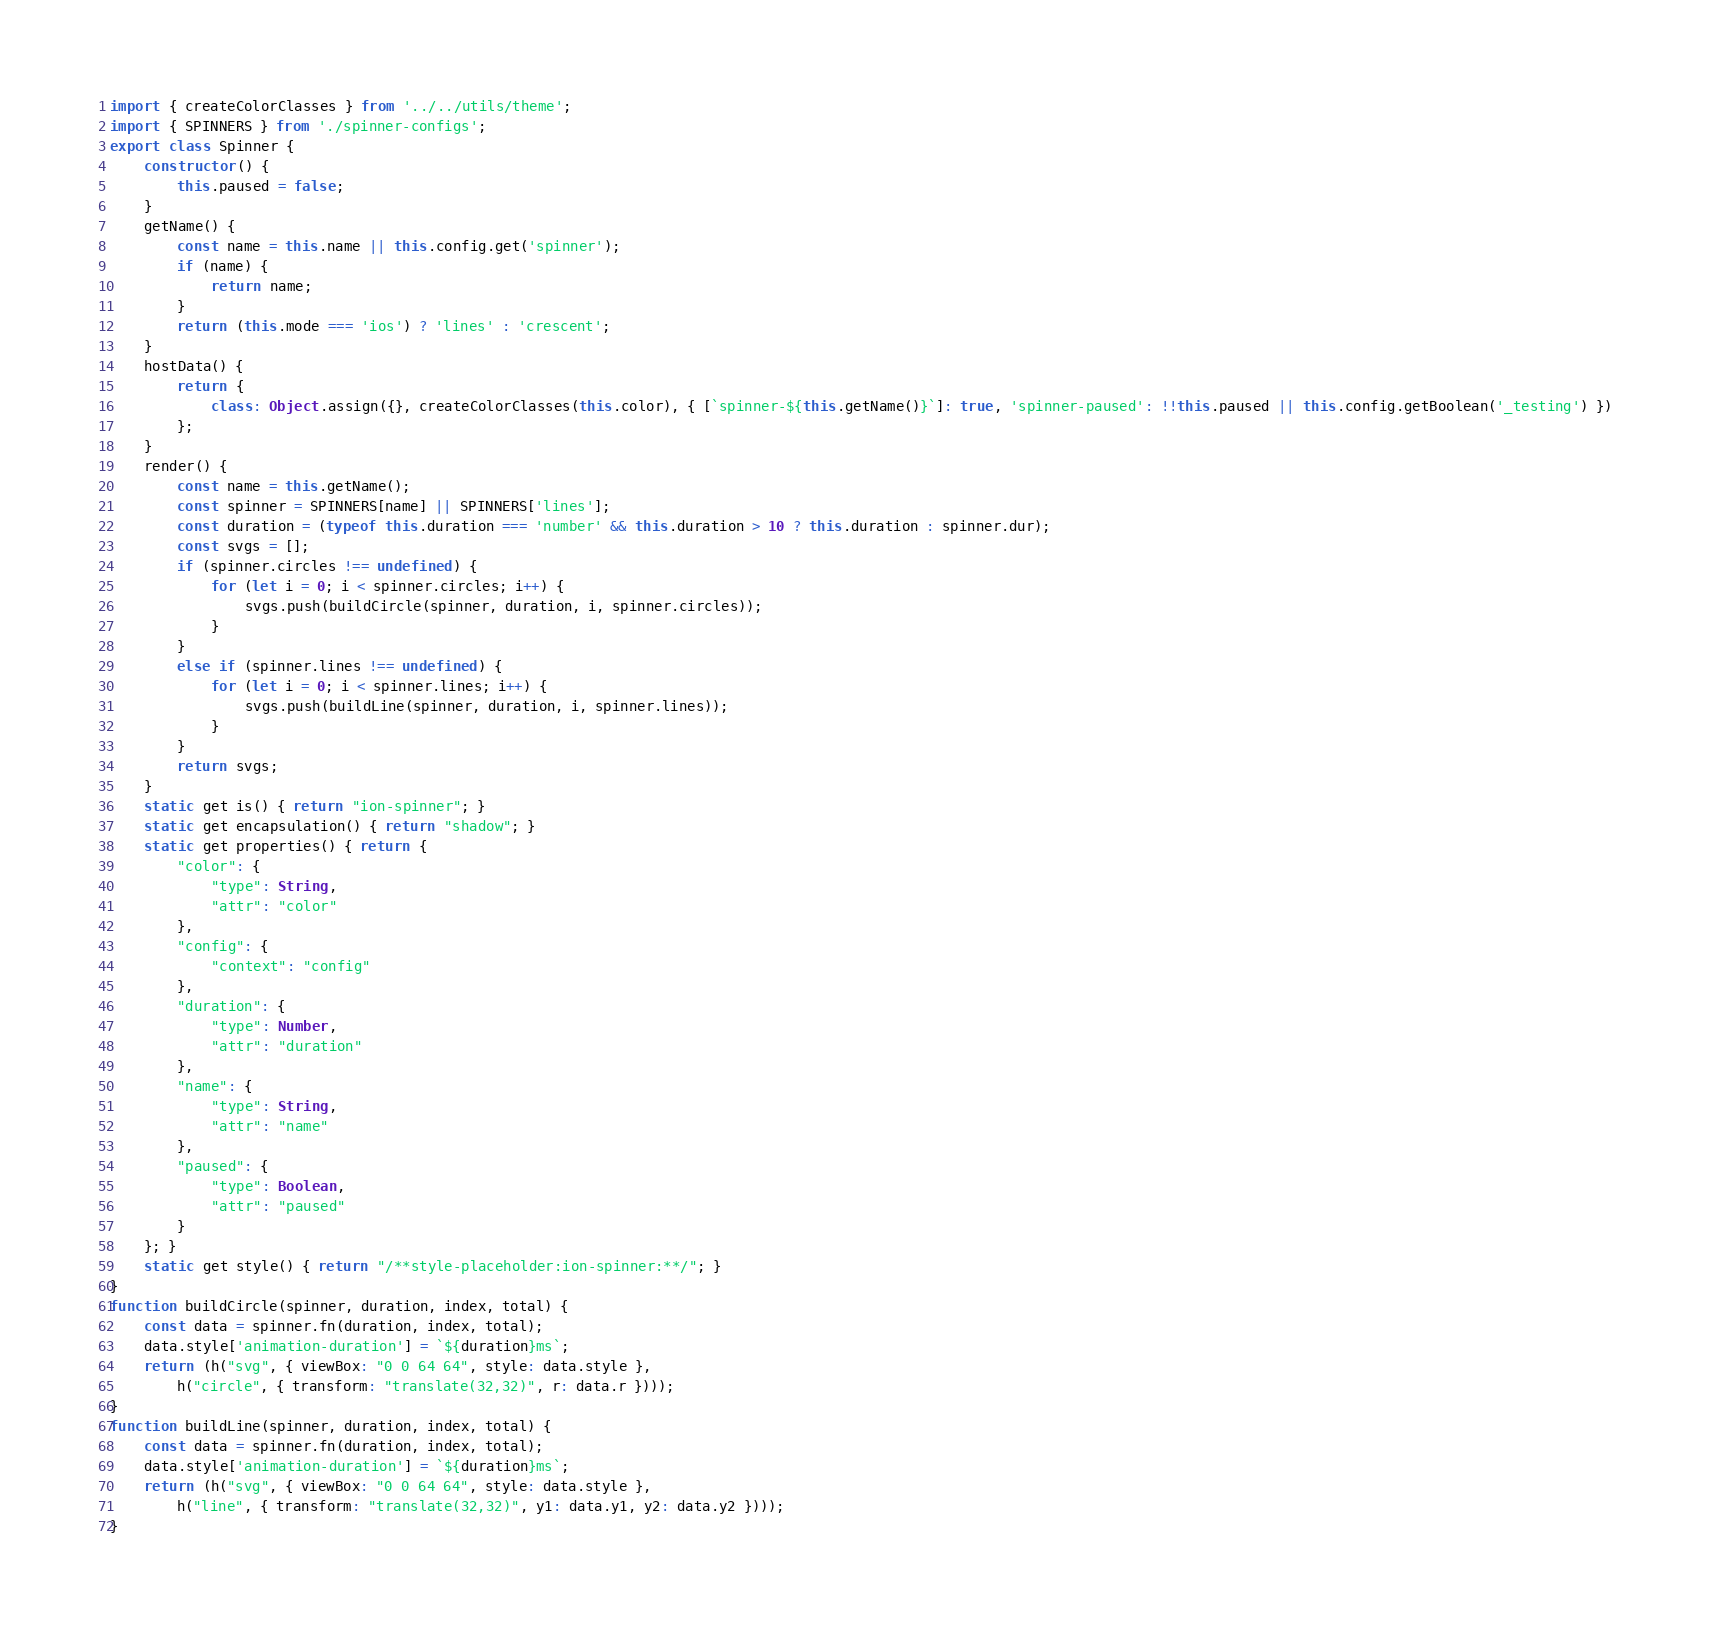Convert code to text. <code><loc_0><loc_0><loc_500><loc_500><_JavaScript_>import { createColorClasses } from '../../utils/theme';
import { SPINNERS } from './spinner-configs';
export class Spinner {
    constructor() {
        this.paused = false;
    }
    getName() {
        const name = this.name || this.config.get('spinner');
        if (name) {
            return name;
        }
        return (this.mode === 'ios') ? 'lines' : 'crescent';
    }
    hostData() {
        return {
            class: Object.assign({}, createColorClasses(this.color), { [`spinner-${this.getName()}`]: true, 'spinner-paused': !!this.paused || this.config.getBoolean('_testing') })
        };
    }
    render() {
        const name = this.getName();
        const spinner = SPINNERS[name] || SPINNERS['lines'];
        const duration = (typeof this.duration === 'number' && this.duration > 10 ? this.duration : spinner.dur);
        const svgs = [];
        if (spinner.circles !== undefined) {
            for (let i = 0; i < spinner.circles; i++) {
                svgs.push(buildCircle(spinner, duration, i, spinner.circles));
            }
        }
        else if (spinner.lines !== undefined) {
            for (let i = 0; i < spinner.lines; i++) {
                svgs.push(buildLine(spinner, duration, i, spinner.lines));
            }
        }
        return svgs;
    }
    static get is() { return "ion-spinner"; }
    static get encapsulation() { return "shadow"; }
    static get properties() { return {
        "color": {
            "type": String,
            "attr": "color"
        },
        "config": {
            "context": "config"
        },
        "duration": {
            "type": Number,
            "attr": "duration"
        },
        "name": {
            "type": String,
            "attr": "name"
        },
        "paused": {
            "type": Boolean,
            "attr": "paused"
        }
    }; }
    static get style() { return "/**style-placeholder:ion-spinner:**/"; }
}
function buildCircle(spinner, duration, index, total) {
    const data = spinner.fn(duration, index, total);
    data.style['animation-duration'] = `${duration}ms`;
    return (h("svg", { viewBox: "0 0 64 64", style: data.style },
        h("circle", { transform: "translate(32,32)", r: data.r })));
}
function buildLine(spinner, duration, index, total) {
    const data = spinner.fn(duration, index, total);
    data.style['animation-duration'] = `${duration}ms`;
    return (h("svg", { viewBox: "0 0 64 64", style: data.style },
        h("line", { transform: "translate(32,32)", y1: data.y1, y2: data.y2 })));
}
</code> 